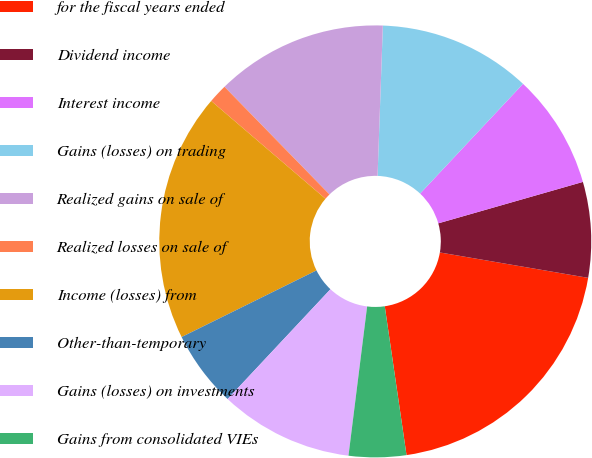<chart> <loc_0><loc_0><loc_500><loc_500><pie_chart><fcel>for the fiscal years ended<fcel>Dividend income<fcel>Interest income<fcel>Gains (losses) on trading<fcel>Realized gains on sale of<fcel>Realized losses on sale of<fcel>Income (losses) from<fcel>Other-than-temporary<fcel>Gains (losses) on investments<fcel>Gains from consolidated VIEs<nl><fcel>19.99%<fcel>7.14%<fcel>8.57%<fcel>11.43%<fcel>12.86%<fcel>1.43%<fcel>18.57%<fcel>5.72%<fcel>10.0%<fcel>4.29%<nl></chart> 